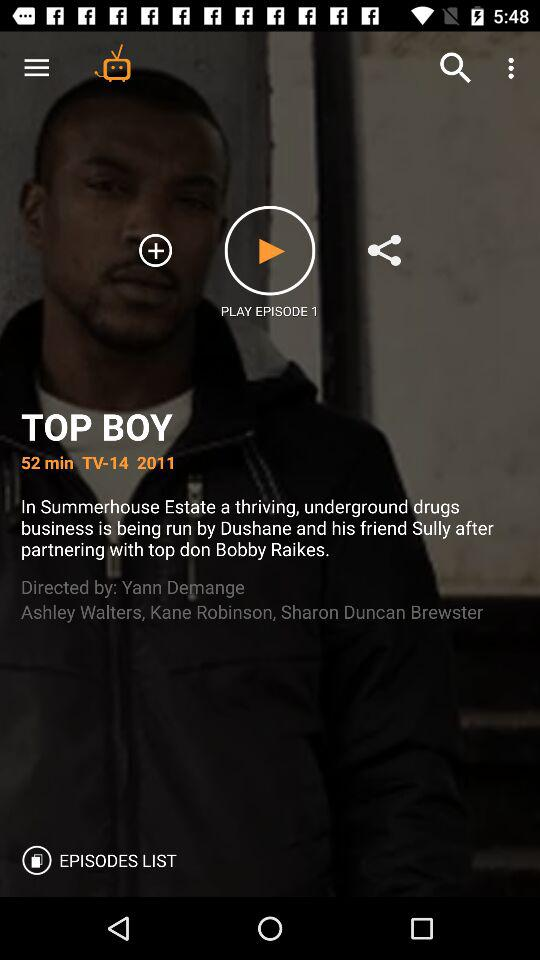Who directed the top boy? The top boy is directed by Yann Demange. 